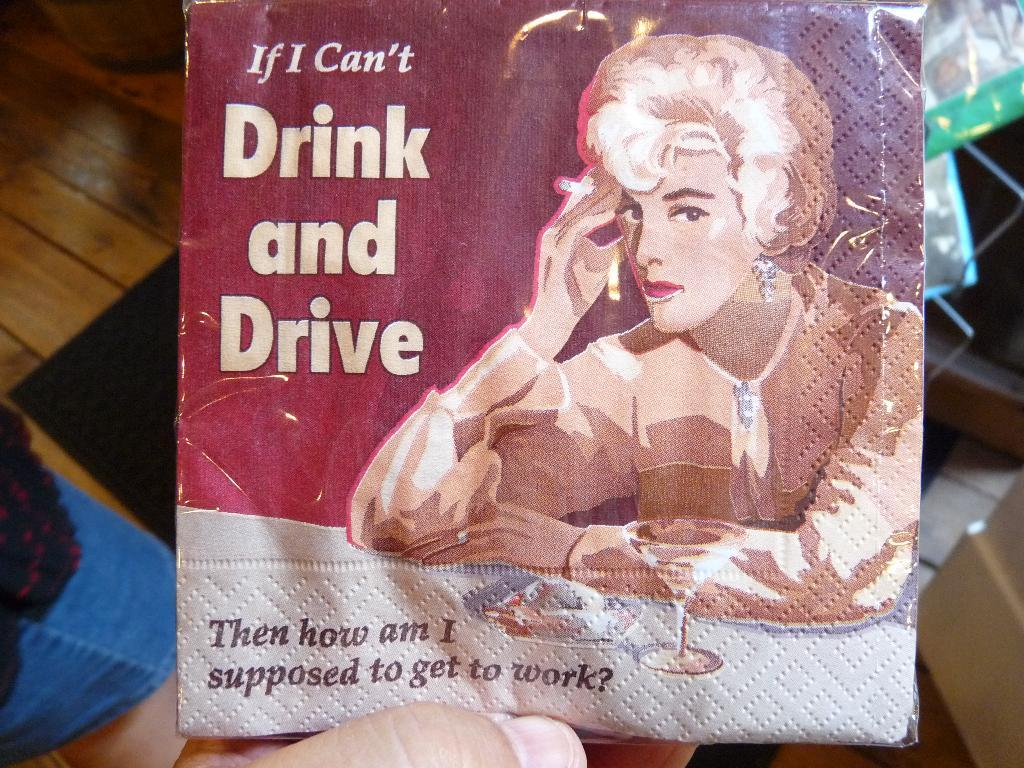What is the main subject of the image? The main subject of the image is a cover with a print on it. Can you describe any additional details about the image? A person's finger is visible at the bottom of the image, and the image is on a wooden table. What can be seen in the background of the image? There are objects visible in the background of the image. What color is the crayon that the crow is holding in the image? There is no crayon or crow present in the image. 